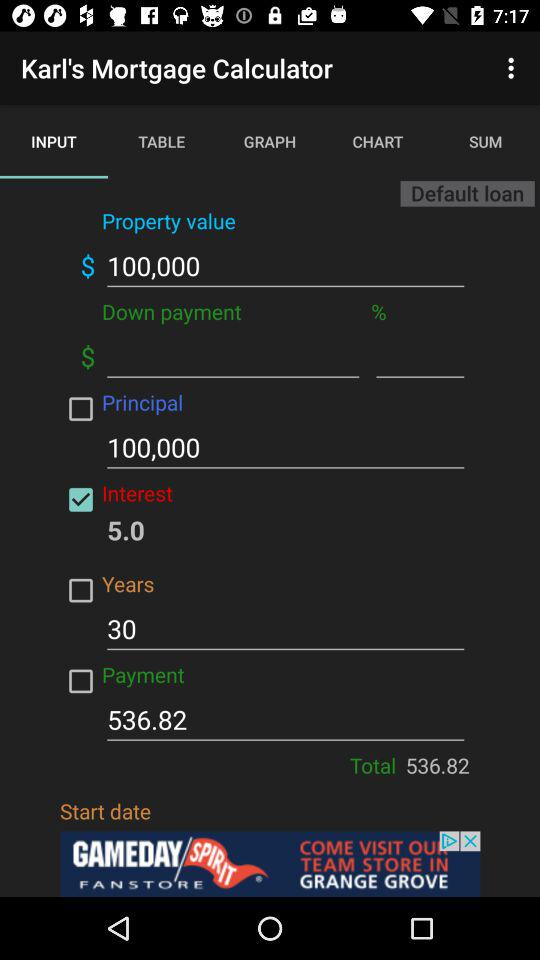What is the name of the application? The name of the application is "Karl's Mortgage Calculator". 